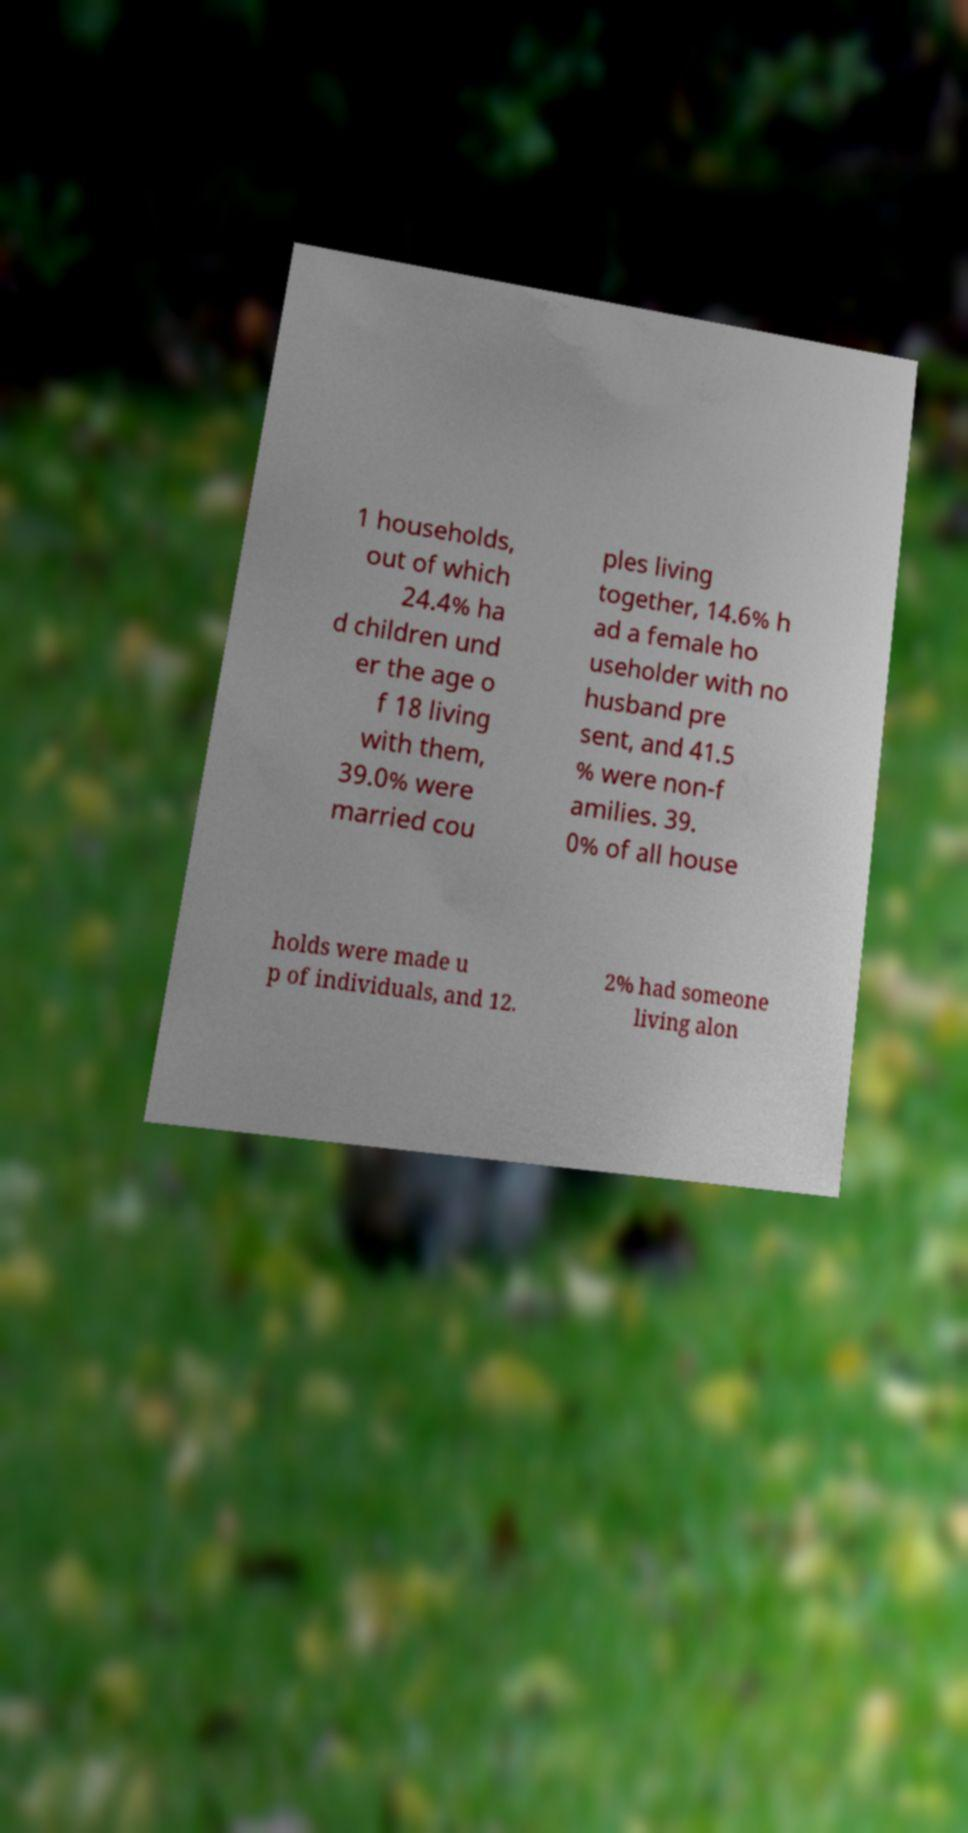Please identify and transcribe the text found in this image. 1 households, out of which 24.4% ha d children und er the age o f 18 living with them, 39.0% were married cou ples living together, 14.6% h ad a female ho useholder with no husband pre sent, and 41.5 % were non-f amilies. 39. 0% of all house holds were made u p of individuals, and 12. 2% had someone living alon 